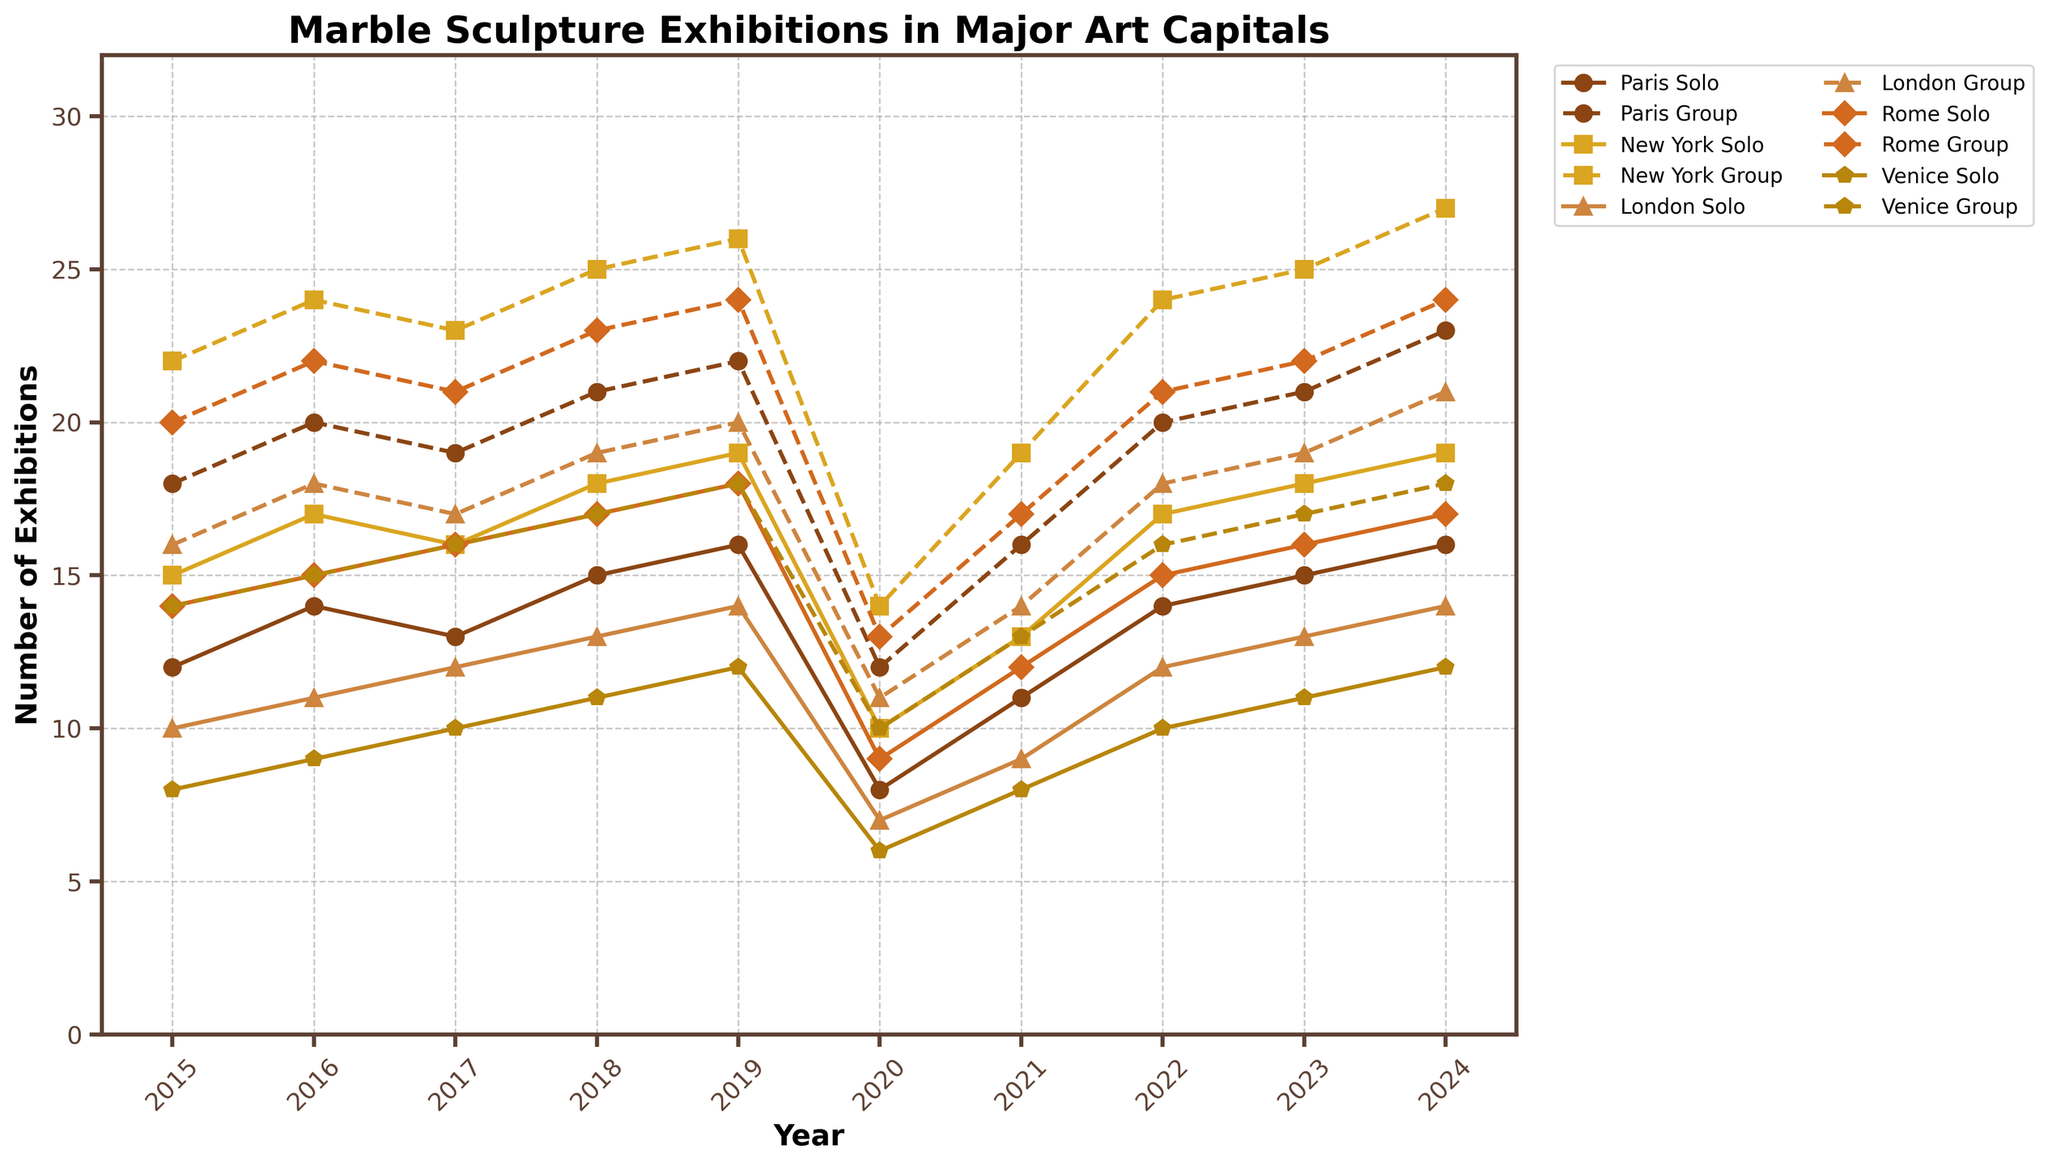How did the number of solo exhibitions in Paris change from 2020 to 2024? The figure shows the annual number of solo exhibitions in Paris indicated by a line. In 2020, there were 8 solo exhibitions, and by 2024 there were 16.
Answer: It doubled Which city had more group exhibitions in 2023, New York or Rome? Look at the lines for group exhibitions for both cities in 2023. New York had 25 group exhibitions, while Rome had 22 group exhibitions.
Answer: New York What is the trend for solo exhibitions in London from 2015 to 2024? Observe the line representing solo exhibitions in London over the years. The chart shows an increasing trend, starting at 10 in 2015 and reaching 14 in 2024. It dipped slightly during 2020 but then resumed an upward trend.
Answer: Increasing Which city had the least total number of exhibitions (both solo and group) in the year 2020? Sum the solo and group exhibitions for each city in 2020. Paris: 8+12=20, New York: 10+14=24, London: 7+11=18, Rome: 9+13=22, Venice: 6+10=16.
Answer: Venice How did group exhibitions in Venice in 2015 compare to 2020? Compare the height of the lines representing group exhibitions for Venice in 2015 and 2020. In 2015, there were 14 group exhibitions, while in 2020 there were 10. The decrease is by 4.
Answer: Decreased by 4 Which year saw the highest number of group exhibitions in New York? Find the peak point for New York's group exhibitions on the timeline. The highest number is 27 in 2024.
Answer: 2024 What is the average number of group exhibitions in Rome from 2015 to 2024? Find the sum of group exhibitions from 2015 to 2024 and divide by the number of years. Sum = 20 + 22 + 21 + 23 + 24 + 13 + 17 + 21 + 22 + 24, which is 207. There are 10 years. 207/10 = 20.7
Answer: 20.7 Are solo or group exhibitions more common in Venice in the years 2015 and 2024? Compare the values for solo and group exhibitions in Venice for both years. In 2015: Solo (8) < Group (14), and in 2024: Solo (12) < Group (18).
Answer: Group exhibitions What was the total number of solo exhibitions held across all cities in 2022? Sum up the values for solo exhibitions in 2022 across all cities: Paris (14), New York (17), London (12), Rome (15), Venice (10). 14 + 17 + 12 + 15 + 10 = 68
Answer: 68 